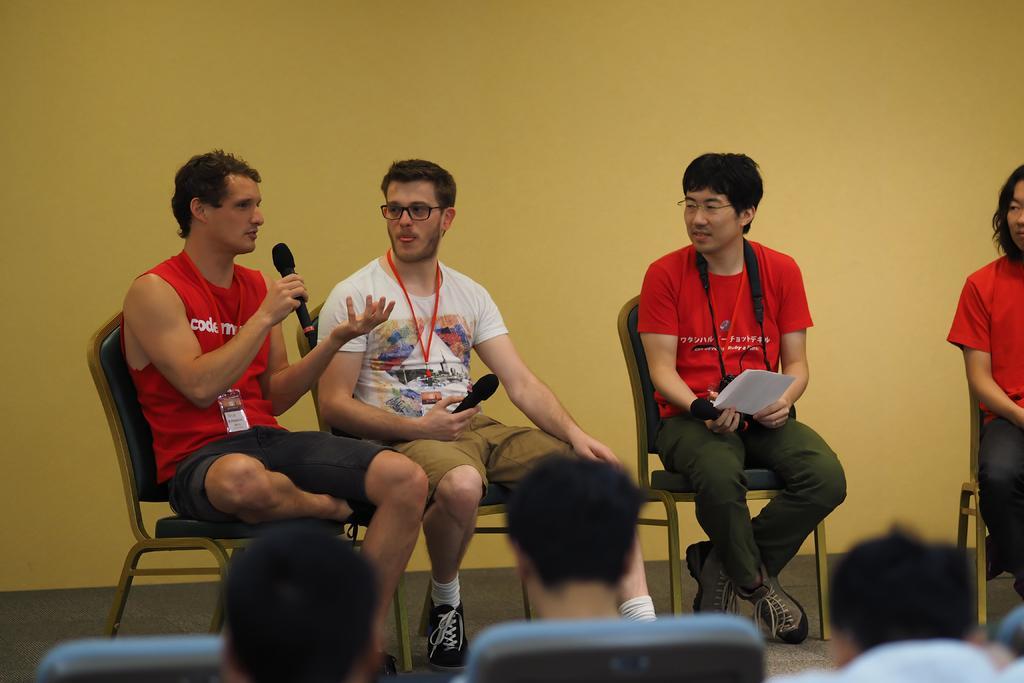Can you describe this image briefly? In this image, we can see people sitting on the chairs and some are holding objects in their hands and some are wearing id cards. In the background, there is a wall. 